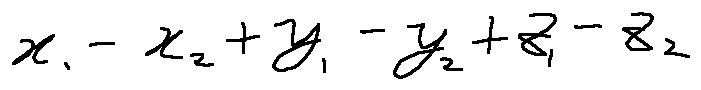<formula> <loc_0><loc_0><loc_500><loc_500>x _ { 1 } - x _ { 2 } + y _ { 1 } - y _ { 2 } + z _ { 1 } - z _ { 2 }</formula> 